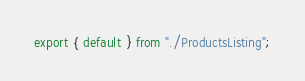<code> <loc_0><loc_0><loc_500><loc_500><_JavaScript_>export { default } from "./ProductsListing";</code> 